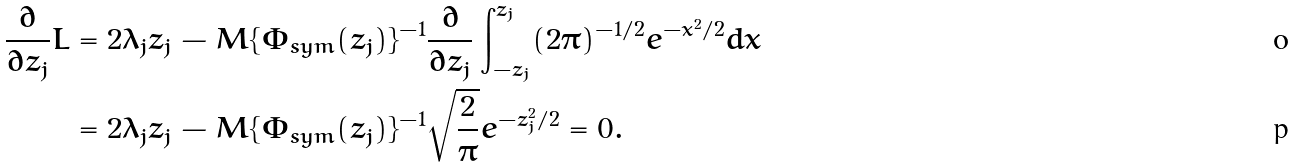<formula> <loc_0><loc_0><loc_500><loc_500>\frac { \partial } { \partial { z _ { j } } } L & = 2 \lambda _ { j } z _ { j } - M \{ \Phi _ { s y m } ( z _ { j } ) \} ^ { - 1 } \frac { \partial } { \partial { z _ { j } } } \int _ { - z _ { j } } ^ { z _ { j } } ( 2 \pi ) ^ { - 1 / 2 } e ^ { - x ^ { 2 } / 2 } d x \\ & = 2 \lambda _ { j } z _ { j } - M \{ \Phi _ { s y m } ( z _ { j } ) \} ^ { - 1 } \sqrt { \frac { 2 } { \pi } } e ^ { - z _ { j } ^ { 2 } / 2 } = 0 .</formula> 